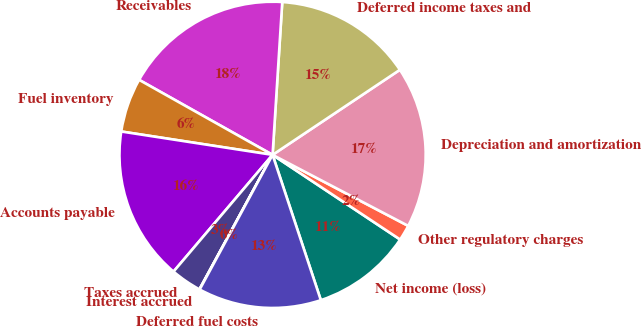Convert chart. <chart><loc_0><loc_0><loc_500><loc_500><pie_chart><fcel>Net income (loss)<fcel>Other regulatory charges<fcel>Depreciation and amortization<fcel>Deferred income taxes and<fcel>Receivables<fcel>Fuel inventory<fcel>Accounts payable<fcel>Taxes accrued<fcel>Interest accrued<fcel>Deferred fuel costs<nl><fcel>10.57%<fcel>1.65%<fcel>17.05%<fcel>14.62%<fcel>17.86%<fcel>5.71%<fcel>16.24%<fcel>3.27%<fcel>0.03%<fcel>13.0%<nl></chart> 